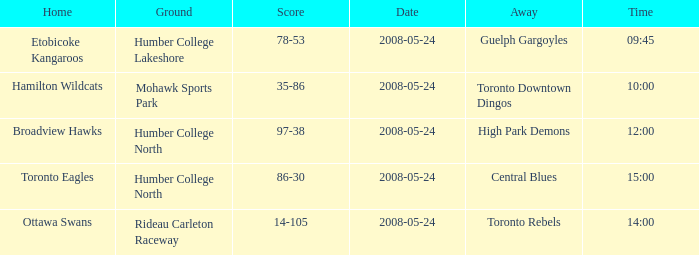On what grounds did the away team of the Toronto Rebels play? Rideau Carleton Raceway. Help me parse the entirety of this table. {'header': ['Home', 'Ground', 'Score', 'Date', 'Away', 'Time'], 'rows': [['Etobicoke Kangaroos', 'Humber College Lakeshore', '78-53', '2008-05-24', 'Guelph Gargoyles', '09:45'], ['Hamilton Wildcats', 'Mohawk Sports Park', '35-86', '2008-05-24', 'Toronto Downtown Dingos', '10:00'], ['Broadview Hawks', 'Humber College North', '97-38', '2008-05-24', 'High Park Demons', '12:00'], ['Toronto Eagles', 'Humber College North', '86-30', '2008-05-24', 'Central Blues', '15:00'], ['Ottawa Swans', 'Rideau Carleton Raceway', '14-105', '2008-05-24', 'Toronto Rebels', '14:00']]} 